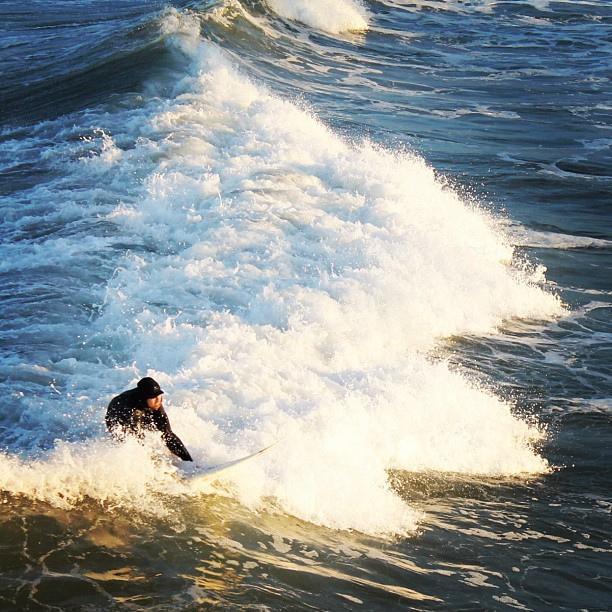How many zebras have their faces showing in the image?
Give a very brief answer. 0. 